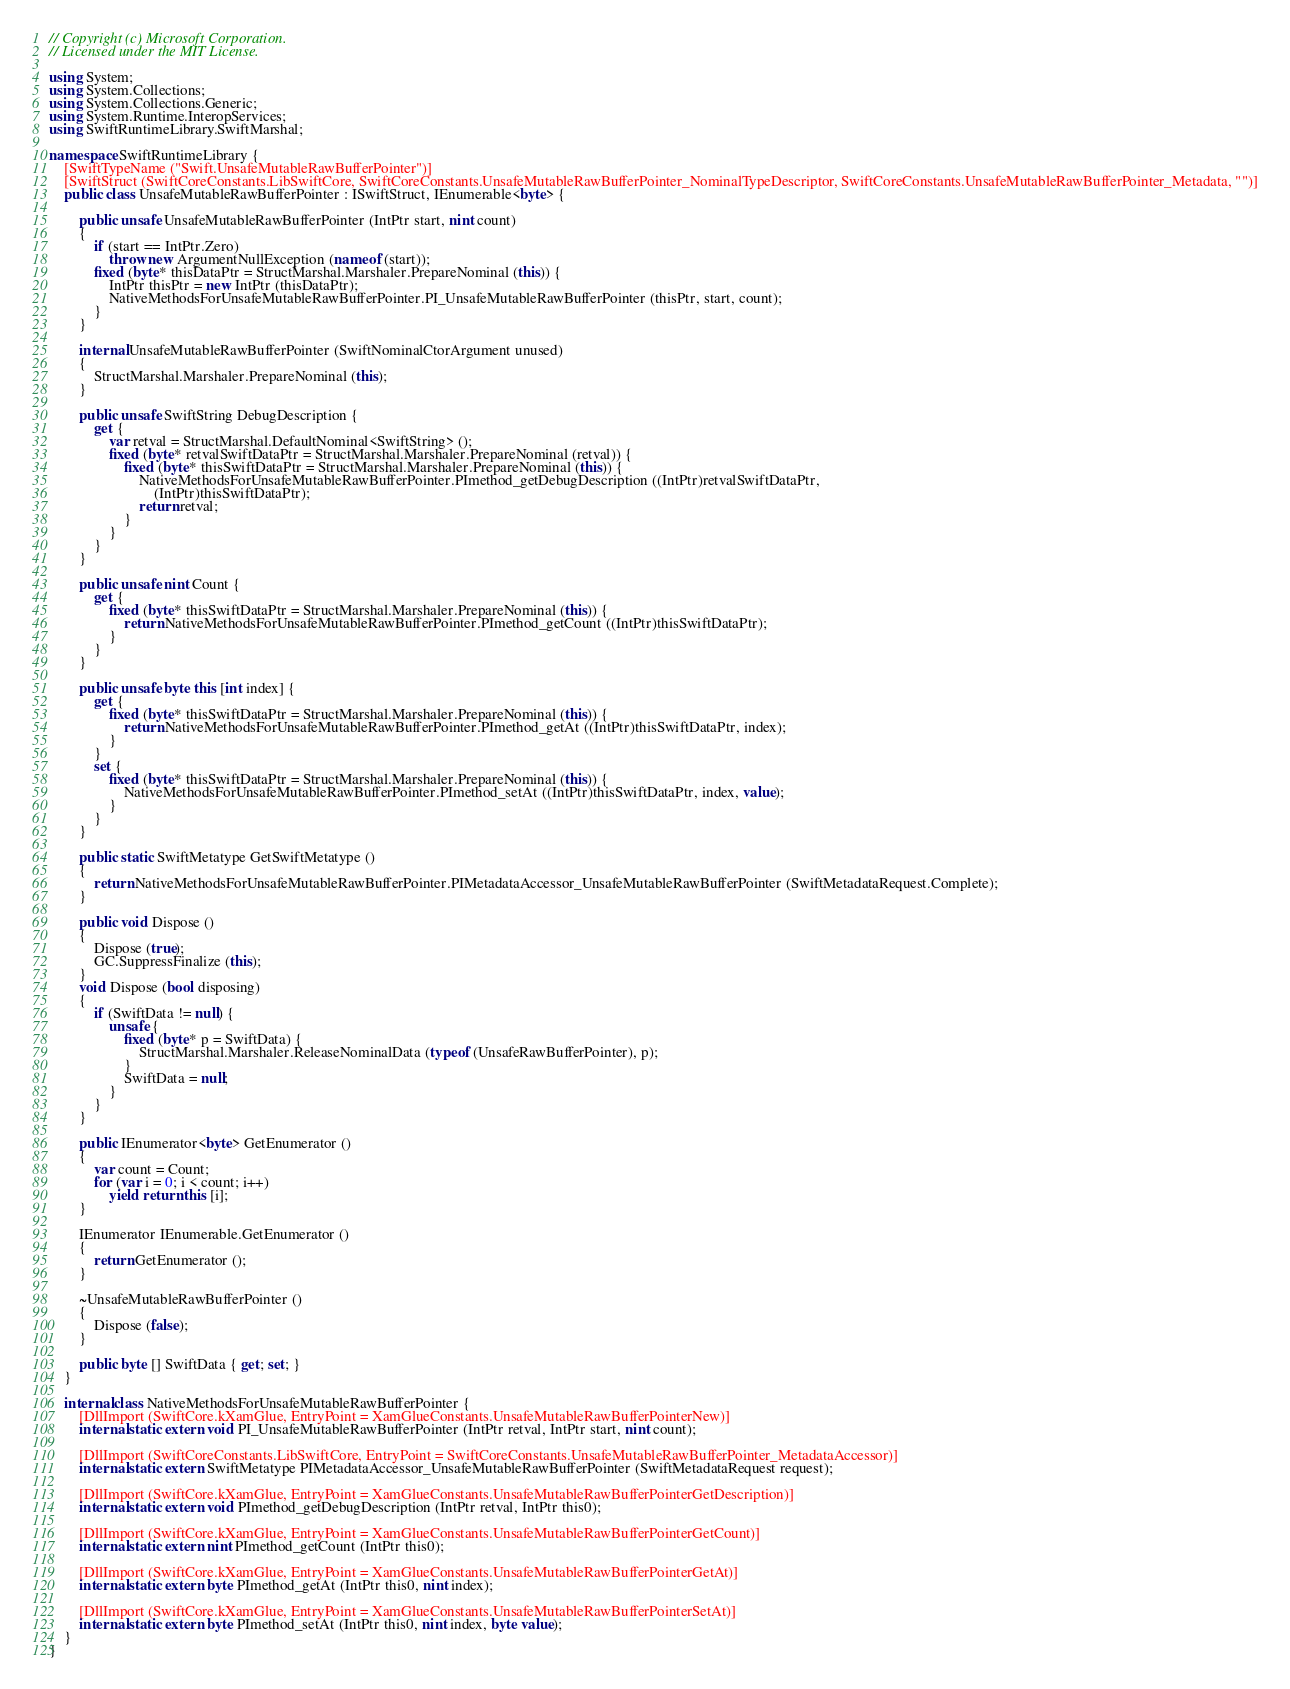Convert code to text. <code><loc_0><loc_0><loc_500><loc_500><_C#_>// Copyright (c) Microsoft Corporation.
// Licensed under the MIT License.

using System;
using System.Collections;
using System.Collections.Generic;
using System.Runtime.InteropServices;
using SwiftRuntimeLibrary.SwiftMarshal;

namespace SwiftRuntimeLibrary {
	[SwiftTypeName ("Swift.UnsafeMutableRawBufferPointer")]
	[SwiftStruct (SwiftCoreConstants.LibSwiftCore, SwiftCoreConstants.UnsafeMutableRawBufferPointer_NominalTypeDescriptor, SwiftCoreConstants.UnsafeMutableRawBufferPointer_Metadata, "")]
	public class UnsafeMutableRawBufferPointer : ISwiftStruct, IEnumerable<byte> {

		public unsafe UnsafeMutableRawBufferPointer (IntPtr start, nint count)
		{
			if (start == IntPtr.Zero)
				throw new ArgumentNullException (nameof (start));
			fixed (byte* thisDataPtr = StructMarshal.Marshaler.PrepareNominal (this)) {
				IntPtr thisPtr = new IntPtr (thisDataPtr);
				NativeMethodsForUnsafeMutableRawBufferPointer.PI_UnsafeMutableRawBufferPointer (thisPtr, start, count);
			}
		}

		internal UnsafeMutableRawBufferPointer (SwiftNominalCtorArgument unused)
		{
			StructMarshal.Marshaler.PrepareNominal (this);
		}

		public unsafe SwiftString DebugDescription {
			get {
				var retval = StructMarshal.DefaultNominal<SwiftString> ();
				fixed (byte* retvalSwiftDataPtr = StructMarshal.Marshaler.PrepareNominal (retval)) {
					fixed (byte* thisSwiftDataPtr = StructMarshal.Marshaler.PrepareNominal (this)) {
						NativeMethodsForUnsafeMutableRawBufferPointer.PImethod_getDebugDescription ((IntPtr)retvalSwiftDataPtr,
						    (IntPtr)thisSwiftDataPtr);
						return retval;
					}
				}
			}
		}

		public unsafe nint Count {
			get {
				fixed (byte* thisSwiftDataPtr = StructMarshal.Marshaler.PrepareNominal (this)) {
					return NativeMethodsForUnsafeMutableRawBufferPointer.PImethod_getCount ((IntPtr)thisSwiftDataPtr);
				}
			}
		}

		public unsafe byte this [int index] {
			get {
				fixed (byte* thisSwiftDataPtr = StructMarshal.Marshaler.PrepareNominal (this)) {
					return NativeMethodsForUnsafeMutableRawBufferPointer.PImethod_getAt ((IntPtr)thisSwiftDataPtr, index);
				}
			}
			set {
				fixed (byte* thisSwiftDataPtr = StructMarshal.Marshaler.PrepareNominal (this)) {
					NativeMethodsForUnsafeMutableRawBufferPointer.PImethod_setAt ((IntPtr)thisSwiftDataPtr, index, value);
				}
			}
		}

		public static SwiftMetatype GetSwiftMetatype ()
		{
			return NativeMethodsForUnsafeMutableRawBufferPointer.PIMetadataAccessor_UnsafeMutableRawBufferPointer (SwiftMetadataRequest.Complete);
		}

		public void Dispose ()
		{
			Dispose (true);
			GC.SuppressFinalize (this);
		}
		void Dispose (bool disposing)
		{
			if (SwiftData != null) {
				unsafe {
					fixed (byte* p = SwiftData) {
						StructMarshal.Marshaler.ReleaseNominalData (typeof (UnsafeRawBufferPointer), p);
					}
					SwiftData = null;
				}
			}
		}

		public IEnumerator<byte> GetEnumerator ()
		{
			var count = Count;
			for (var i = 0; i < count; i++)
				yield return this [i];
		}

		IEnumerator IEnumerable.GetEnumerator ()
		{
			return GetEnumerator ();
		}

		~UnsafeMutableRawBufferPointer ()
		{
			Dispose (false);
		}

		public byte [] SwiftData { get; set; }
	}

	internal class NativeMethodsForUnsafeMutableRawBufferPointer {
		[DllImport (SwiftCore.kXamGlue, EntryPoint = XamGlueConstants.UnsafeMutableRawBufferPointerNew)]
		internal static extern void PI_UnsafeMutableRawBufferPointer (IntPtr retval, IntPtr start, nint count);

		[DllImport (SwiftCoreConstants.LibSwiftCore, EntryPoint = SwiftCoreConstants.UnsafeMutableRawBufferPointer_MetadataAccessor)]
		internal static extern SwiftMetatype PIMetadataAccessor_UnsafeMutableRawBufferPointer (SwiftMetadataRequest request);

		[DllImport (SwiftCore.kXamGlue, EntryPoint = XamGlueConstants.UnsafeMutableRawBufferPointerGetDescription)]
		internal static extern void PImethod_getDebugDescription (IntPtr retval, IntPtr this0);

		[DllImport (SwiftCore.kXamGlue, EntryPoint = XamGlueConstants.UnsafeMutableRawBufferPointerGetCount)]
		internal static extern nint PImethod_getCount (IntPtr this0);

		[DllImport (SwiftCore.kXamGlue, EntryPoint = XamGlueConstants.UnsafeMutableRawBufferPointerGetAt)]
		internal static extern byte PImethod_getAt (IntPtr this0, nint index);

		[DllImport (SwiftCore.kXamGlue, EntryPoint = XamGlueConstants.UnsafeMutableRawBufferPointerSetAt)]
		internal static extern byte PImethod_setAt (IntPtr this0, nint index, byte value);
	}
}
</code> 